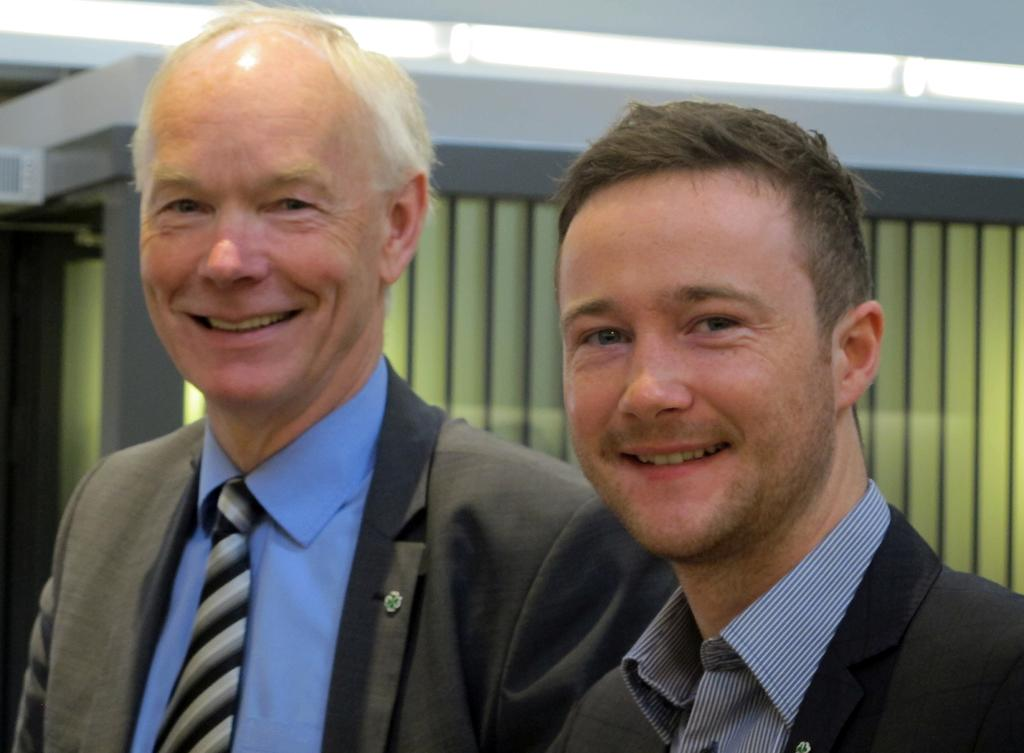How many people are in the image? There are two people standing in the center of the image. What are the people doing in the image? The people are smiling in the image. What are the people wearing in the image? The people are wearing suits in the image. What can be seen in the background of the image? There is a wall and lights in the background of the image. How many cats are sitting on the people's heads in the image? There are no cats present in the image. What type of thread is being used to stitch the people's minds together in the image? There is no thread or mention of stitching the people's minds together in the image. 